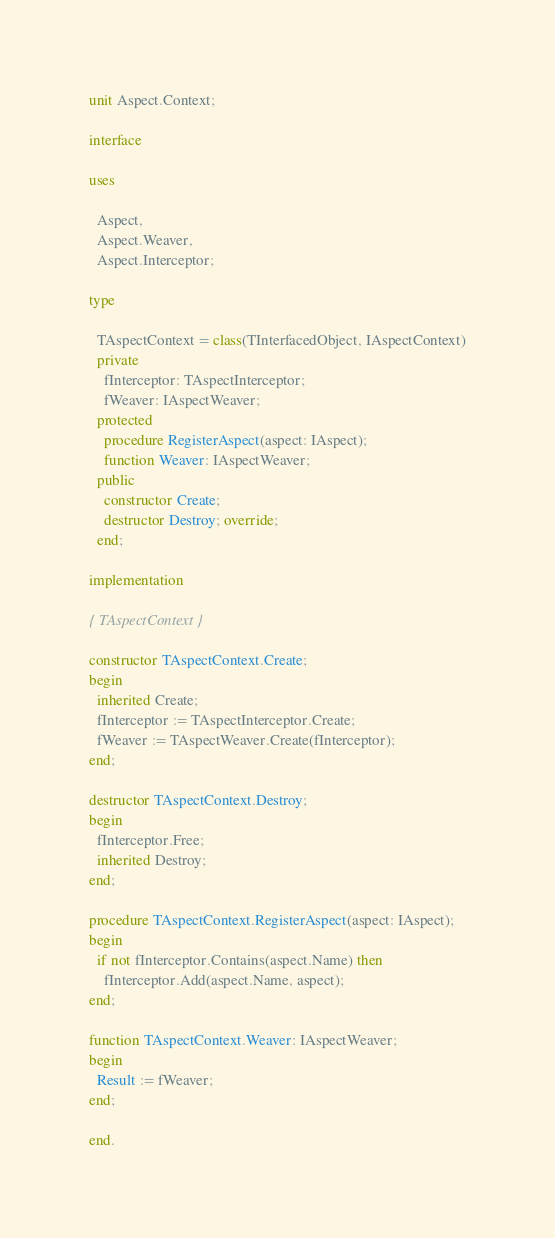Convert code to text. <code><loc_0><loc_0><loc_500><loc_500><_Pascal_>unit Aspect.Context;

interface

uses

  Aspect,
  Aspect.Weaver,
  Aspect.Interceptor;

type

  TAspectContext = class(TInterfacedObject, IAspectContext)
  private
    fInterceptor: TAspectInterceptor;
    fWeaver: IAspectWeaver;
  protected
    procedure RegisterAspect(aspect: IAspect);
    function Weaver: IAspectWeaver;
  public
    constructor Create;
    destructor Destroy; override;
  end;

implementation

{ TAspectContext }

constructor TAspectContext.Create;
begin
  inherited Create;
  fInterceptor := TAspectInterceptor.Create;
  fWeaver := TAspectWeaver.Create(fInterceptor);
end;

destructor TAspectContext.Destroy;
begin
  fInterceptor.Free;
  inherited Destroy;
end;

procedure TAspectContext.RegisterAspect(aspect: IAspect);
begin
  if not fInterceptor.Contains(aspect.Name) then
    fInterceptor.Add(aspect.Name, aspect);
end;

function TAspectContext.Weaver: IAspectWeaver;
begin
  Result := fWeaver;
end;

end.
</code> 